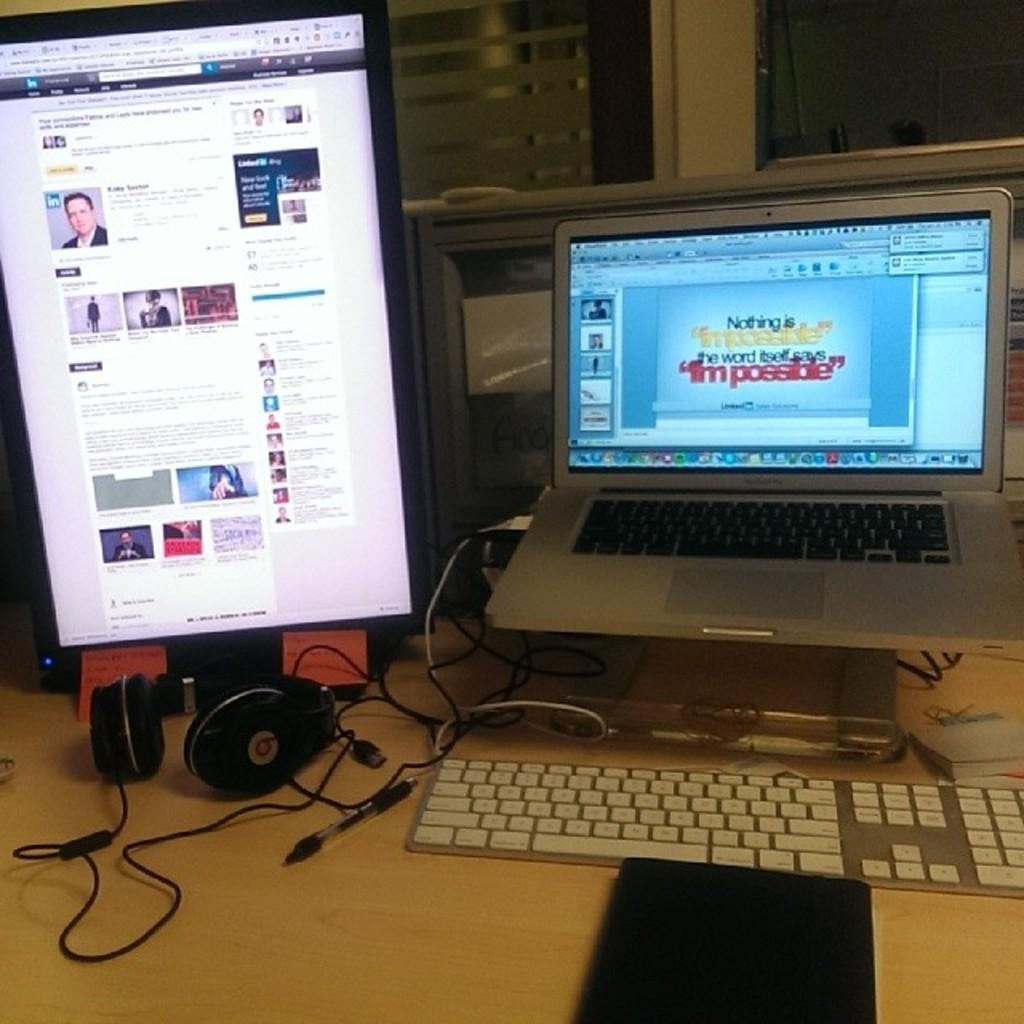<image>
Render a clear and concise summary of the photo. A laptop screen displays a program with the text "nothing is impossible." 